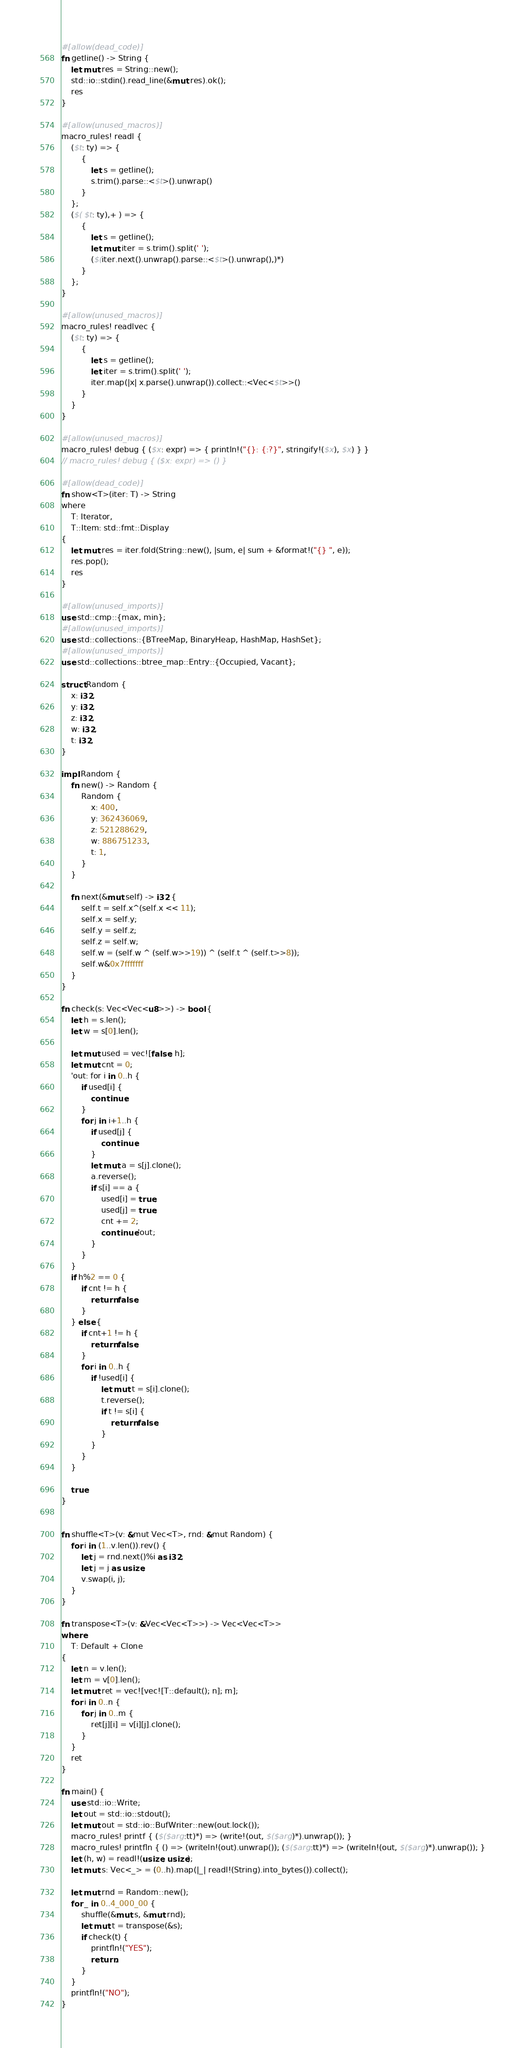<code> <loc_0><loc_0><loc_500><loc_500><_Rust_>#[allow(dead_code)]
fn getline() -> String {
    let mut res = String::new();
    std::io::stdin().read_line(&mut res).ok();
    res
}

#[allow(unused_macros)]
macro_rules! readl {
    ($t: ty) => {
        {
            let s = getline();
            s.trim().parse::<$t>().unwrap()
        }
    };
    ($( $t: ty),+ ) => {
        {
            let s = getline();
            let mut iter = s.trim().split(' ');
            ($(iter.next().unwrap().parse::<$t>().unwrap(),)*)
        }
    };
}

#[allow(unused_macros)]
macro_rules! readlvec {
    ($t: ty) => {
        {
            let s = getline();
            let iter = s.trim().split(' ');
            iter.map(|x| x.parse().unwrap()).collect::<Vec<$t>>()
        }
    }
}

#[allow(unused_macros)]
macro_rules! debug { ($x: expr) => { println!("{}: {:?}", stringify!($x), $x) } }
// macro_rules! debug { ($x: expr) => () }

#[allow(dead_code)]
fn show<T>(iter: T) -> String
where
    T: Iterator,
    T::Item: std::fmt::Display
{
    let mut res = iter.fold(String::new(), |sum, e| sum + &format!("{} ", e));
    res.pop();
    res
}

#[allow(unused_imports)]
use std::cmp::{max, min};
#[allow(unused_imports)]
use std::collections::{BTreeMap, BinaryHeap, HashMap, HashSet};
#[allow(unused_imports)]
use std::collections::btree_map::Entry::{Occupied, Vacant};

struct Random {
    x: i32,
    y: i32,
    z: i32,
    w: i32,
    t: i32,
}

impl Random {
    fn new() -> Random {
        Random {
            x: 400,
            y: 362436069,
            z: 521288629,
            w: 886751233,
            t: 1,
        }
    }

    fn next(&mut self) -> i32 {
        self.t = self.x^(self.x << 11);
        self.x = self.y;
        self.y = self.z;
        self.z = self.w;
        self.w = (self.w ^ (self.w>>19)) ^ (self.t ^ (self.t>>8));
        self.w&0x7fffffff
    }
}

fn check(s: Vec<Vec<u8>>) -> bool {
    let h = s.len();
    let w = s[0].len();

    let mut used = vec![false; h];
    let mut cnt = 0;
    'out: for i in 0..h {
        if used[i] {
            continue;
        }
        for j in i+1..h {
            if used[j] {
                continue;
            }
            let mut a = s[j].clone();
            a.reverse();
            if s[i] == a {
                used[i] = true;
                used[j] = true;
                cnt += 2;
                continue 'out;
            }
        }
    }
    if h%2 == 0 {
        if cnt != h {
            return false;
        }
    } else {
        if cnt+1 != h {
            return false;
        }
        for i in 0..h {
            if !used[i] {
                let mut t = s[i].clone();
                t.reverse();
                if t != s[i] {
                    return false;
                }
            }
        }
    }

    true
}


fn shuffle<T>(v: &mut Vec<T>, rnd: &mut Random) {
    for i in (1..v.len()).rev() {
        let j = rnd.next()%i as i32;
        let j = j as usize;
        v.swap(i, j);
    }
}

fn transpose<T>(v: &Vec<Vec<T>>) -> Vec<Vec<T>> 
where
    T: Default + Clone
{
    let n = v.len();
    let m = v[0].len();
    let mut ret = vec![vec![T::default(); n]; m];
    for i in 0..n {
        for j in 0..m {
            ret[j][i] = v[i][j].clone();
        }
    }
    ret
}

fn main() {
    use std::io::Write;
    let out = std::io::stdout();
    let mut out = std::io::BufWriter::new(out.lock());
    macro_rules! printf { ($($arg:tt)*) => (write!(out, $($arg)*).unwrap()); }
    macro_rules! printfln { () => (writeln!(out).unwrap()); ($($arg:tt)*) => (writeln!(out, $($arg)*).unwrap()); }
    let (h, w) = readl!(usize, usize);
    let mut s: Vec<_> = (0..h).map(|_| readl!(String).into_bytes()).collect();

    let mut rnd = Random::new();
    for _ in 0..4_000_00 {
        shuffle(&mut s, &mut rnd);
        let mut t = transpose(&s);
        if check(t) {
            printfln!("YES");
            return;
        }
    }
    printfln!("NO");
}
</code> 